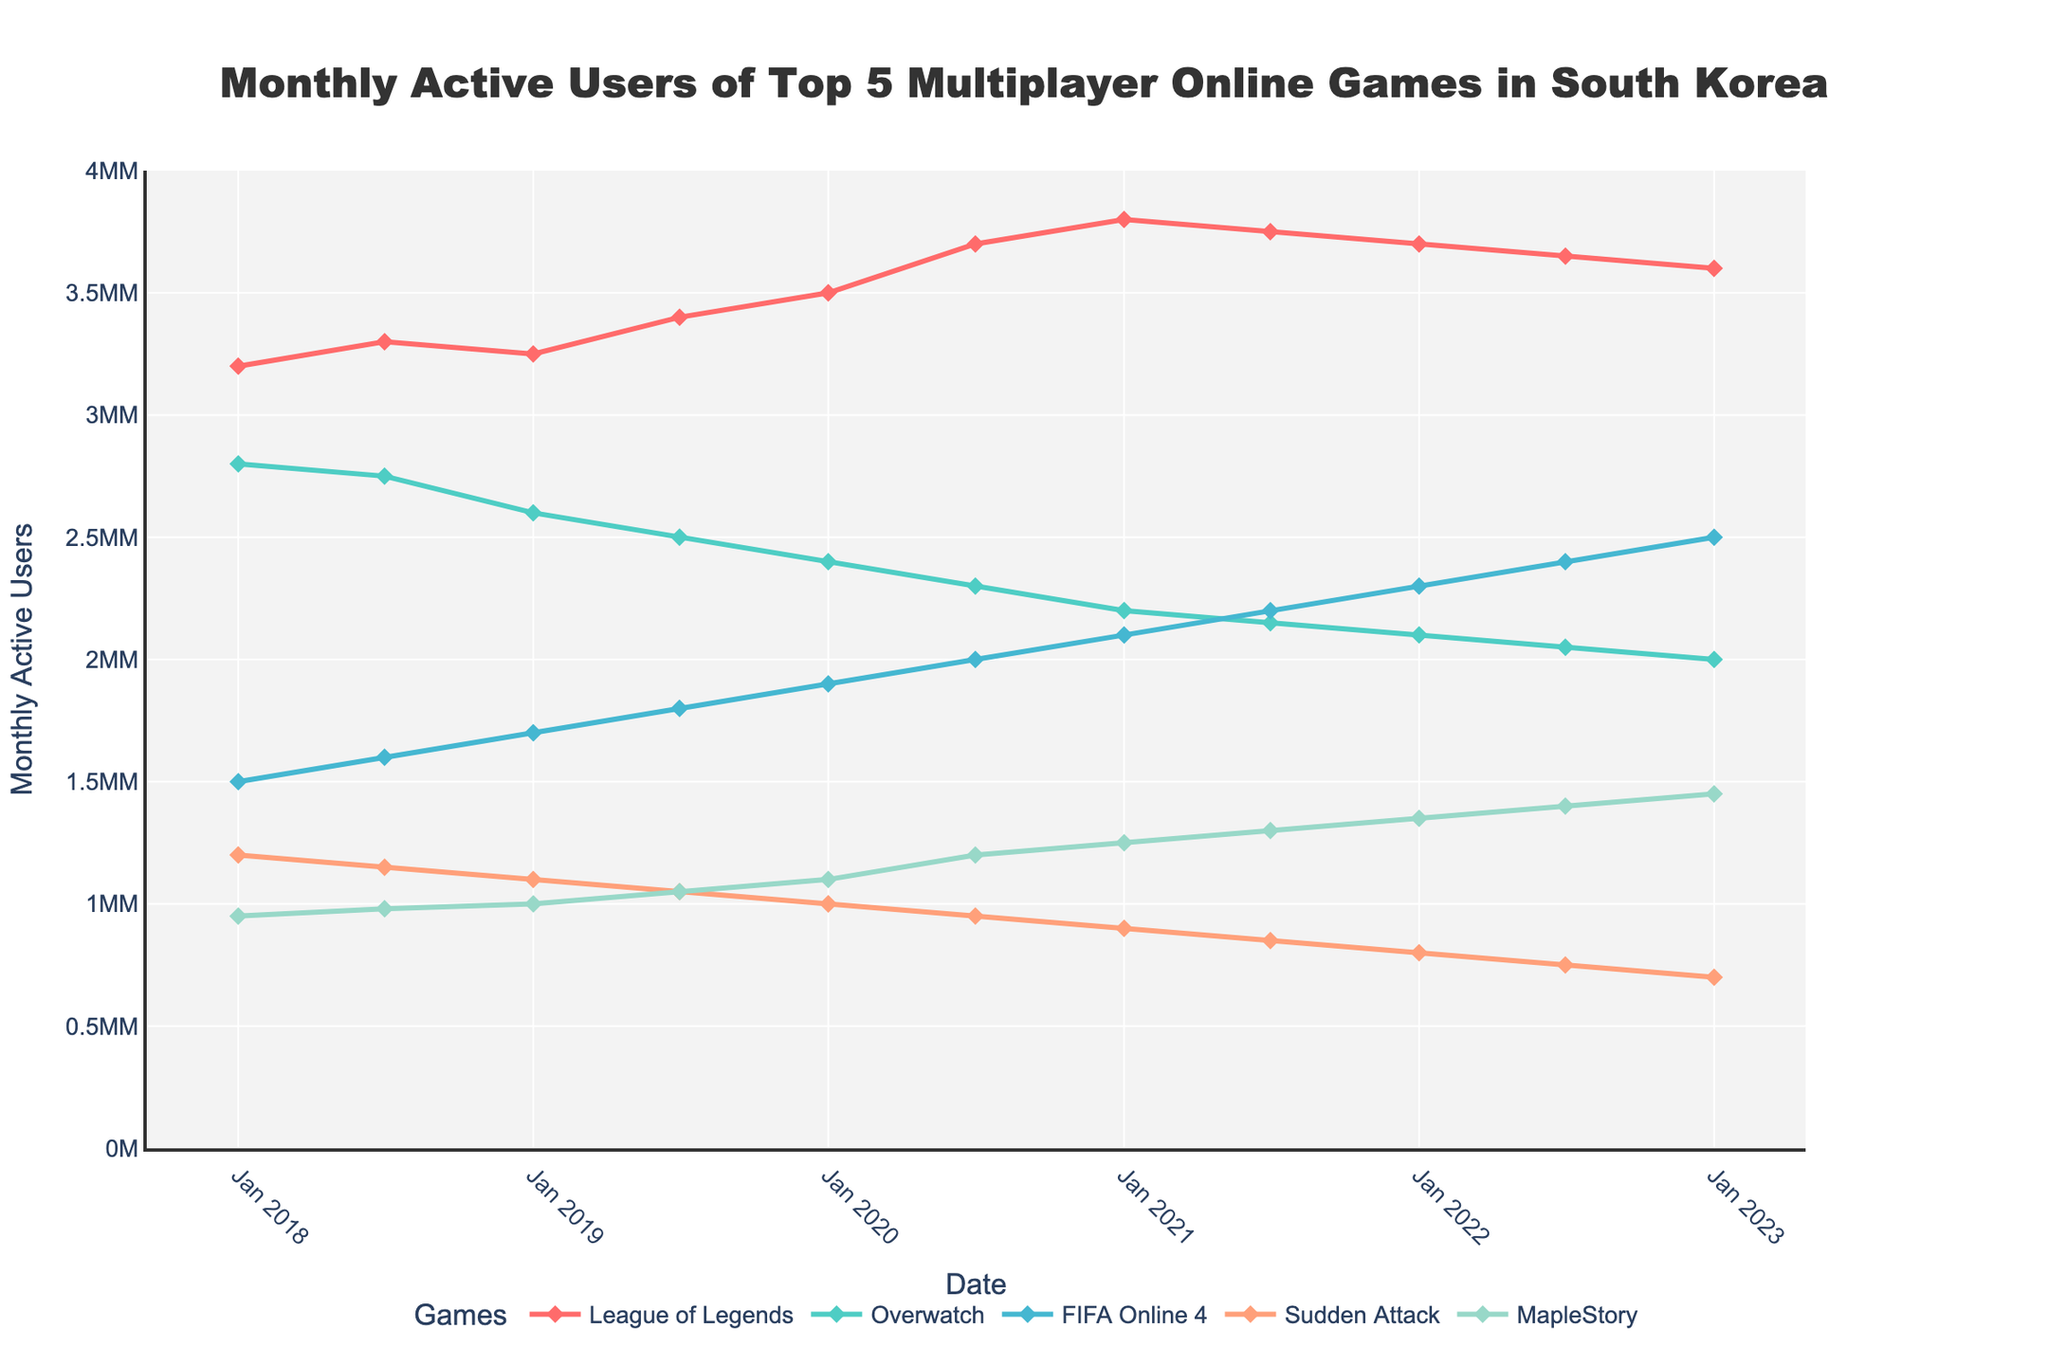What game has the highest number of monthly active users in January 2023? Look at the January 2023 data points and identify the game with the highest y-axis value. League of Legends has 3.6 million, which is the highest value.
Answer: League of Legends Which game had the largest increase in monthly active users between January 2018 and January 2023? Compare the difference in monthly active users from January 2018 to January 2023 for each game. The increases are: League of Legends (400,000), Overwatch (-800,000), FIFA Online 4 (1,000,000), Sudden Attack (-500,000), MapleStory (500,000). FIFA Online 4 had the largest increase.
Answer: FIFA Online 4 During which period did Overwatch experience the largest drop in monthly active users? Examine the lines representing Overwatch and identify the steepest decline. The largest drop occurs between January 2018 (2.8 million) and January 2023 (2 million), specifically between January 2019 (2.6 million) and January 2020 (2.4 million).
Answer: January 2019 to January 2020 In July 2020, what is the combined number of monthly active users for FIFA Online 4 and MapleStory? Look at the y-axis values for July 2020 for FIFA Online 4 (2 million) and MapleStory (1.2 million). Sum these values: 2,000,000 + 1,200,000 = 3,200,000.
Answer: 3,200,000 Which two games have the least number of monthly active users in January 2023, and what are their user counts? Identify the two lowest values from January 2023: Sudden Attack (700,000) and Overwatch (2,000,000).
Answer: Sudden Attack (700,000) and Overwatch (2,000,000) What is the percentage increase in monthly active users for FIFA Online 4 from January 2020 to January 2023? The monthly active users for FIFA Online 4 in January 2020 are 1.9 million and in January 2023 are 2.5 million. Calculate the percentage increase: ((2.5 - 1.9) / 1.9) * 100 = 31.58%.
Answer: 31.58% Comparing July 2018 and July 2022, which game had the most consistent number of monthly active users? Examine the differences between July 2018 and July 2022 for each game: League of Legends (0.35 million), Overwatch (0.7 million), FIFA Online 4 (0.8 million), Sudden Attack (0.4 million), MapleStory (0.42 million). League of Legends shows the smallest change.
Answer: League of Legends What visual trend do you notice in the monthly active users of League of Legends over the period? Observe the line representing League of Legends over the five-year period. It shows a general increasing trend with slight seasonal variations.
Answer: Increasing trend with slight seasonal variations Which game shows a continuous increase in monthly active users from January 2018 to January 2023? By observing the lines, identify the game that doesn't show any decline between data points. FIFA Online 4 shows a continual increase over time.
Answer: FIFA Online 4 How does MapleStory's user base change from July 2020 to January 2021? Look at the data points for MapleStory in July 2020 (1.2 million) and January 2021 (1.25 million). Calculate the difference: 1.25 - 1.2 million = 0.05 million. MapleStory's user base increased by 50,000.
Answer: Increased by 50,000 